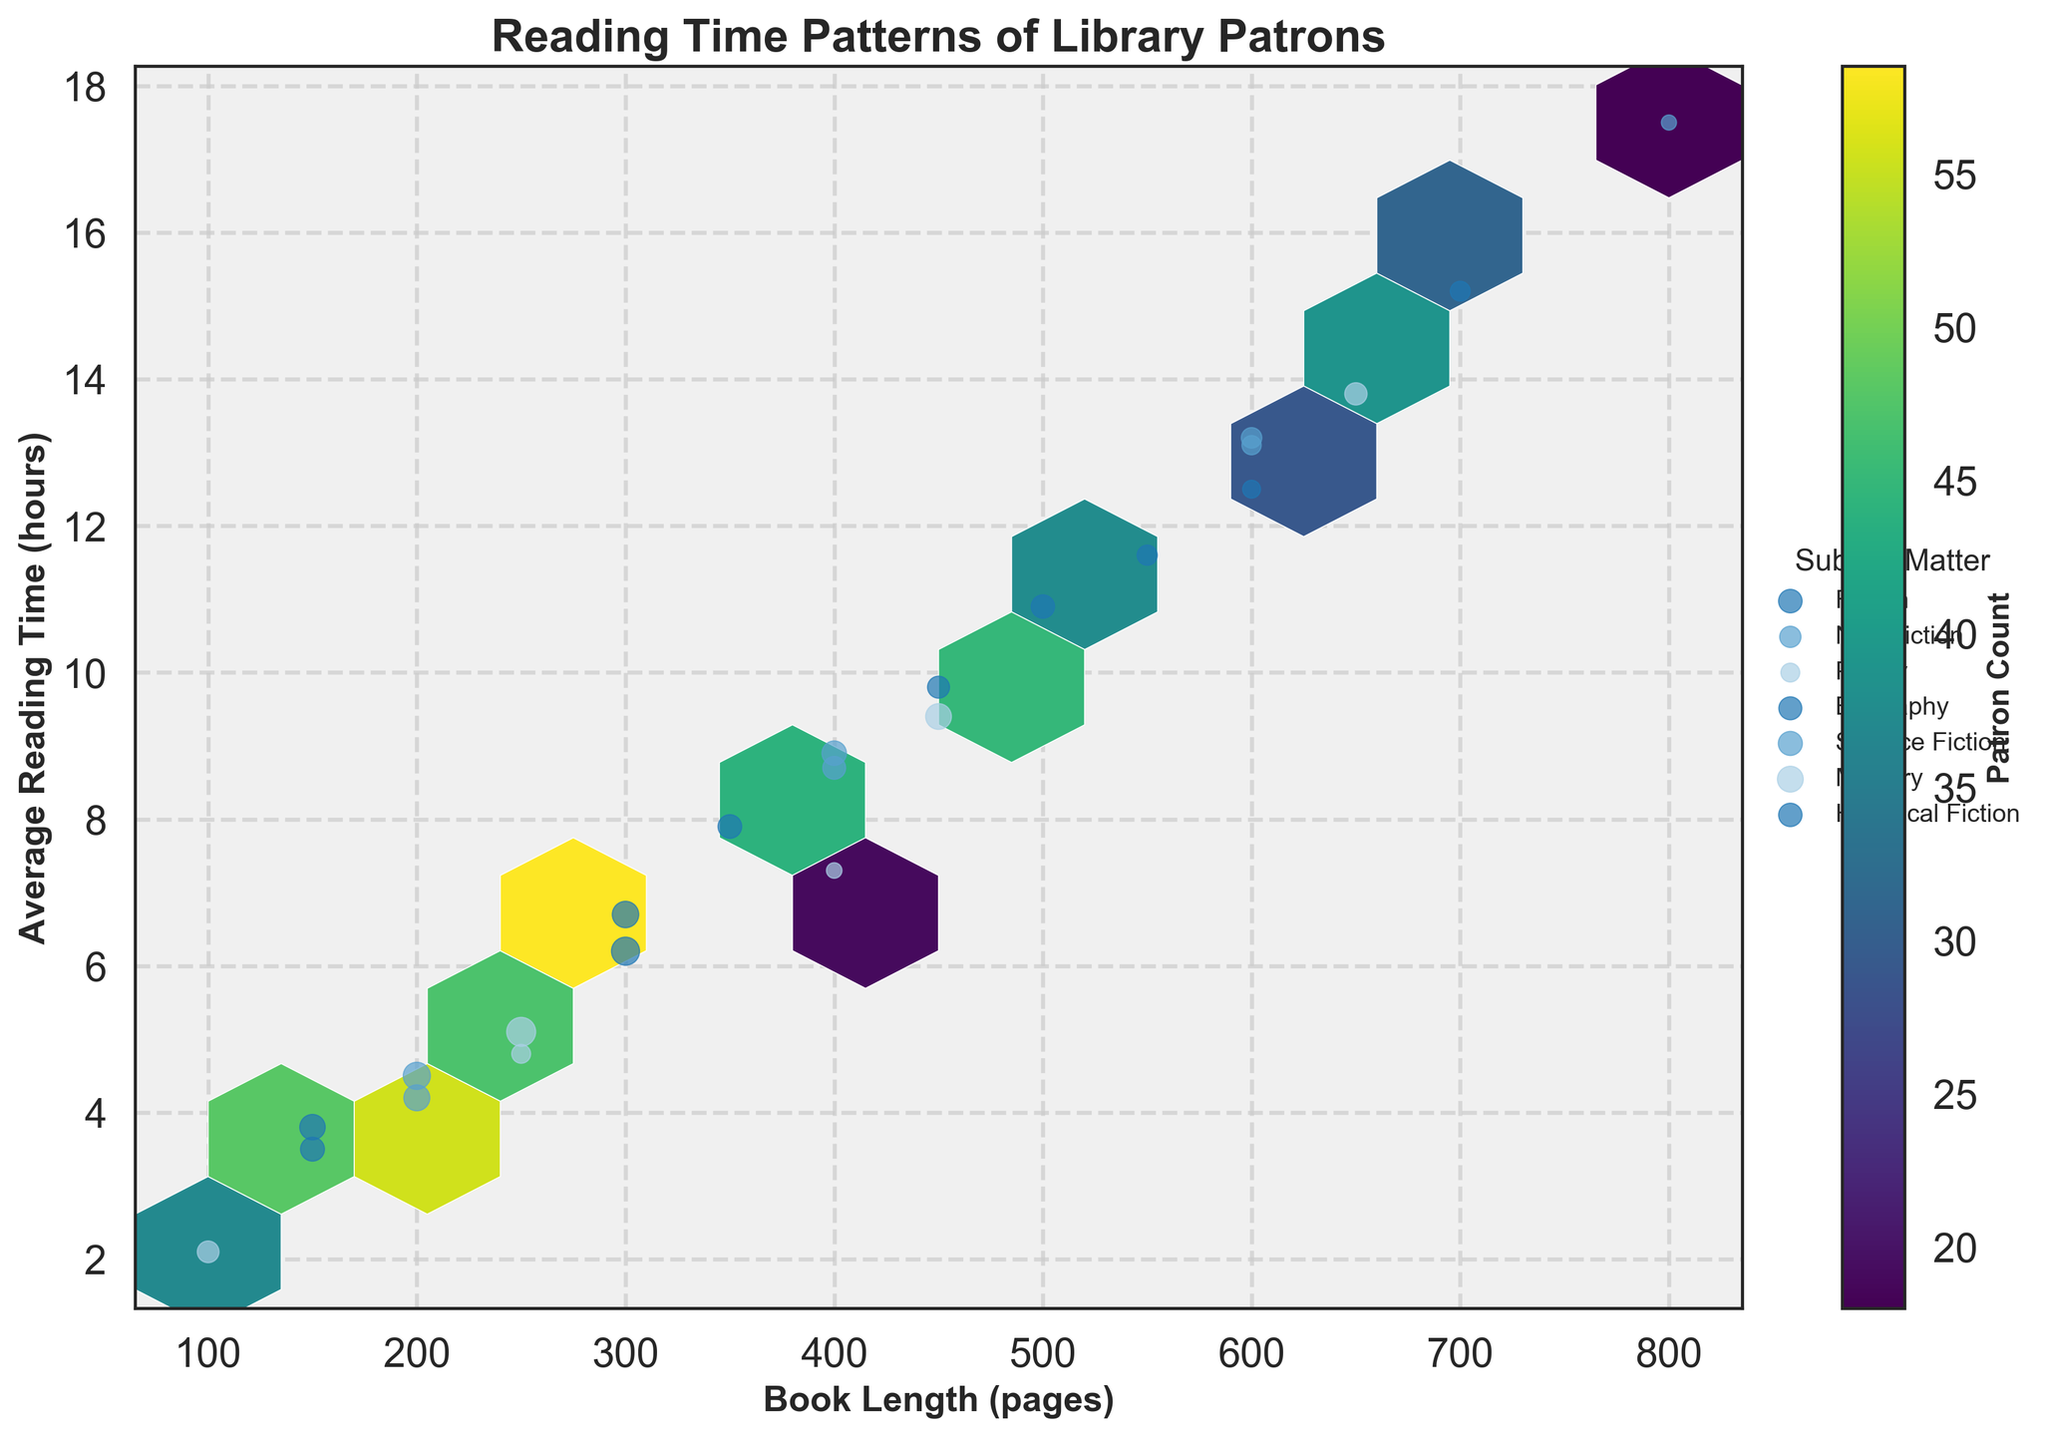What's the title of the plot? The title is typically written at the top of the plot. It describes the overall theme of the plot.
Answer: Reading Time Patterns of Library Patrons What are the labels of the X and Y axes? The X and Y labels are found along the horizontal and vertical axes of the plot, respectively. They provide information about what is being measured on each axis.
Answer: Book Length (pages) and Average Reading Time (hours) What does the color intensity represent in the hexbin plot? The color intensity within the hexagons represents the patron count, with a color bar indicating varying levels of patron count through color changes.
Answer: Patron Count Which subject matter has the highest average reading time for 600-page books? To find this, identify the hexagons or scatter points at 600 pages that show the average reading times, then compare these values across different subject matters.
Answer: Non-Fiction Which book length bracket has the highest average reading time for Fiction books? Look at the scatter points labeled as Fiction and identify the bracket where the average reading time is highest. Assess the corresponding book length.
Answer: 600 pages How does the average reading time change as book length increases for Poetry? Examine the scatter points for Poetry and observe the trend of average reading time as the book length increases.
Answer: The average reading time increases Comparing Science Fiction and Mystery, which one has a higher average reading time for 650-page books? Identify the scatter points for 650-page books and compare the average reading times for Science Fiction and Mystery.
Answer: Mystery What is the primary color scheme used in the hexbin plot? The color scheme refers to the colors used to represent data in the plot, particularly within hexagons. Here, it can be identified by looking at the hexagons and color bar.
Answer: Viridis Which subject matter appears to have the most concentrated cluster of points? The density of points can be estimated by looking at the pattern and clustering in the scatter plot overlay, identifying the subject matter with the highest concentration.
Answer: Fiction Between Biography and Historical Fiction, which subject matter has a higher overall patron count for 500-page books? Find the scatter points at 500-page books for both Biography and Historical Fiction and observe the patron counts indicated by the size of the points.
Answer: Historical Fiction 